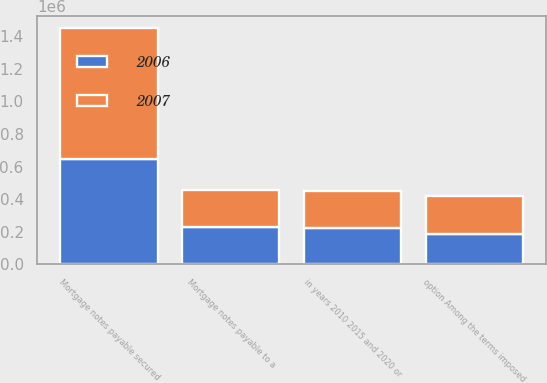Convert chart to OTSL. <chart><loc_0><loc_0><loc_500><loc_500><stacked_bar_chart><ecel><fcel>Mortgage notes payable to a<fcel>Mortgage notes payable secured<fcel>option Among the terms imposed<fcel>in years 2010 2015 and 2020 or<nl><fcel>2007<fcel>224876<fcel>804859<fcel>233138<fcel>225000<nl><fcel>2006<fcel>228663<fcel>645702<fcel>186339<fcel>225000<nl></chart> 